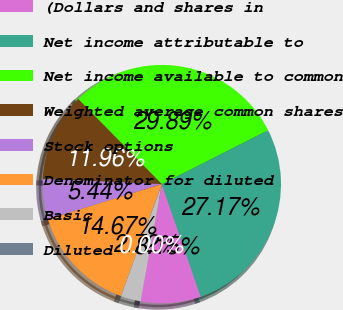<chart> <loc_0><loc_0><loc_500><loc_500><pie_chart><fcel>(Dollars and shares in<fcel>Net income attributable to<fcel>Net income available to common<fcel>Weighted average common shares<fcel>Stock options<fcel>Denominator for diluted<fcel>Basic<fcel>Diluted<nl><fcel>8.15%<fcel>27.17%<fcel>29.89%<fcel>11.96%<fcel>5.44%<fcel>14.67%<fcel>2.72%<fcel>0.0%<nl></chart> 